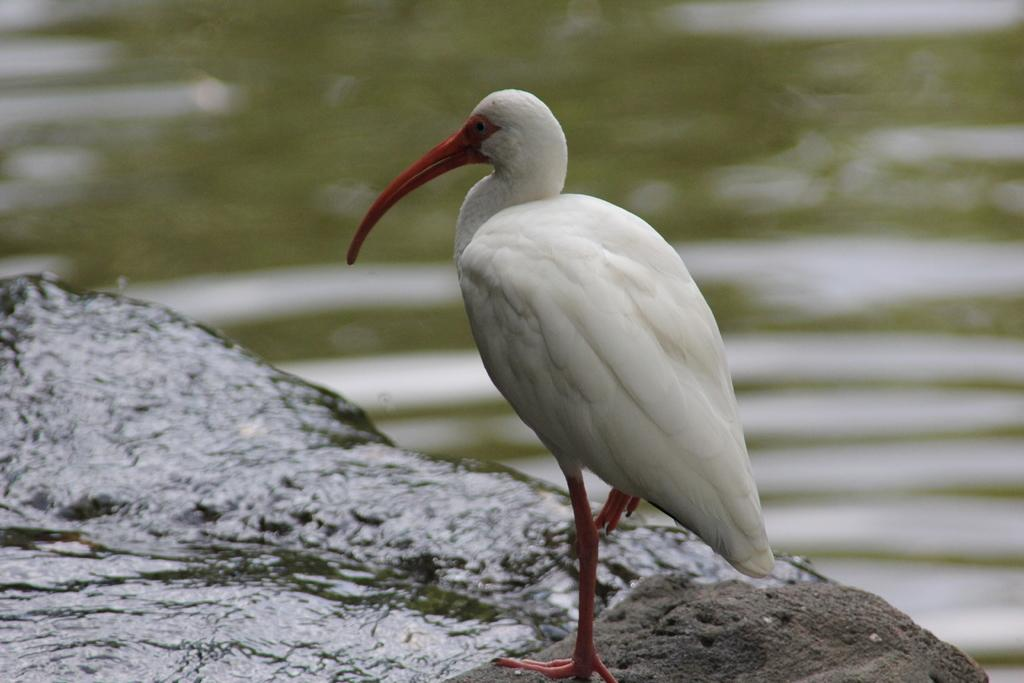What type of animal is in the image? There is a bird in the image. Can you describe the position of the bird in the image? The bird is standing in the front of the image. What is the appearance of the background in the image? The background of the image is blurry. What type of vacation is the bird planning in the image? There is no indication in the image that the bird is planning a vacation. Can you tell me how many planes are visible in the image? There are no planes present in the image. 